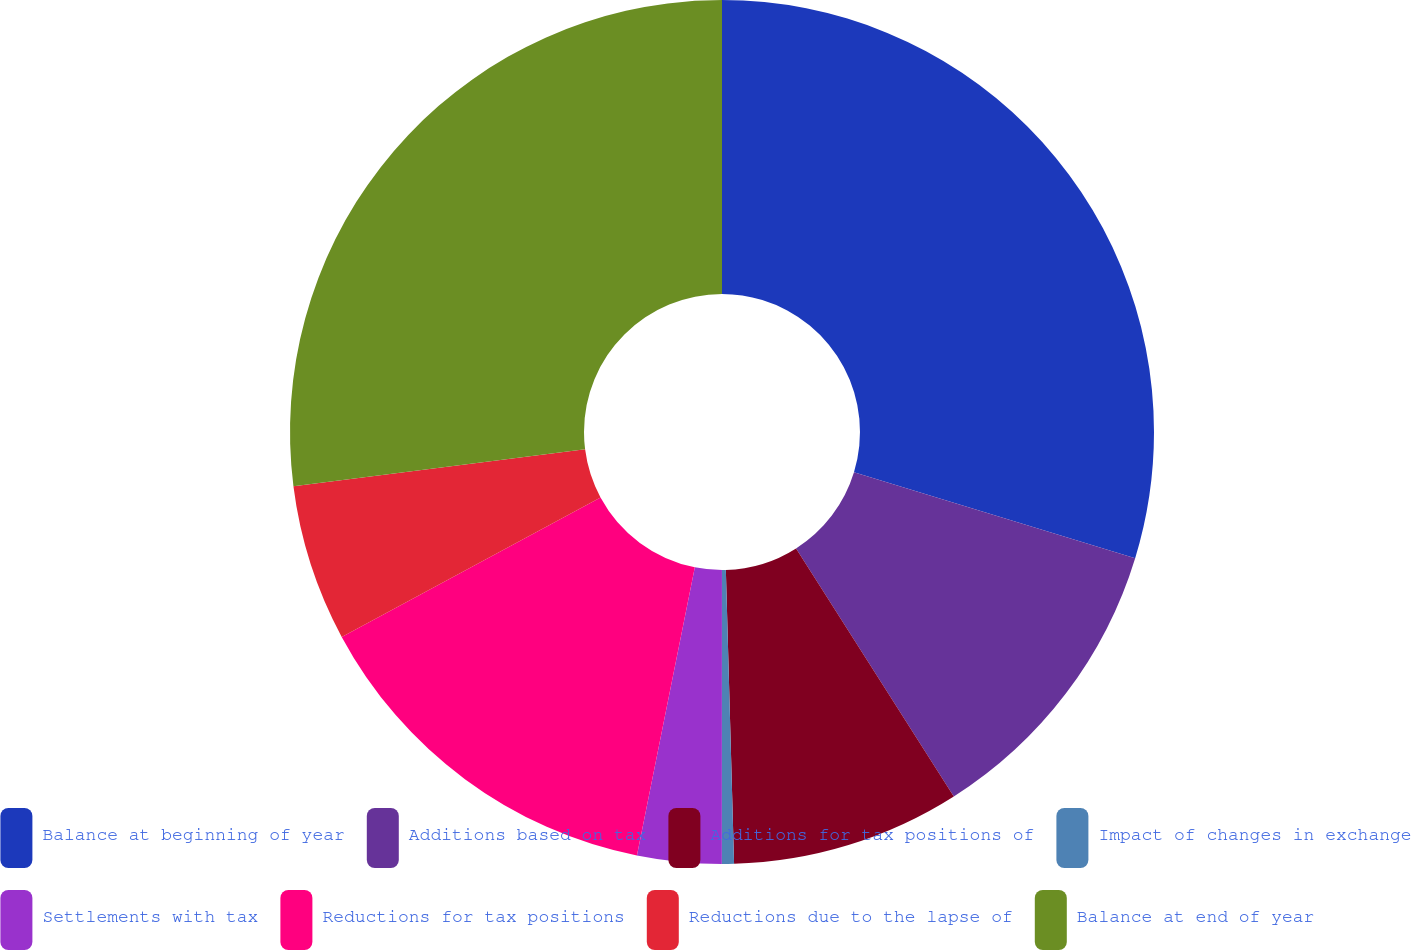Convert chart. <chart><loc_0><loc_0><loc_500><loc_500><pie_chart><fcel>Balance at beginning of year<fcel>Additions based on tax<fcel>Additions for tax positions of<fcel>Impact of changes in exchange<fcel>Settlements with tax<fcel>Reductions for tax positions<fcel>Reductions due to the lapse of<fcel>Balance at end of year<nl><fcel>29.72%<fcel>11.27%<fcel>8.57%<fcel>0.45%<fcel>3.15%<fcel>13.98%<fcel>5.86%<fcel>27.01%<nl></chart> 